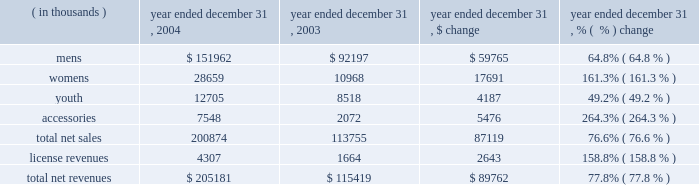2022 selling costs increased $ 5.4 million to $ 17.1 million in 2005 from $ 11.7 million in 2004 .
This increase was due to increased headcount in our sales force and startup costs associated with our international growth initiatives .
As a percentage of net revenues , selling costs increased to 6.1% ( 6.1 % ) in 2005 from 5.7% ( 5.7 % ) in 2004 due to the increased costs described above .
2022 payroll and related costs ( excluding those specifically related to marketing and selling ) increased $ 8.6 million to $ 26.9 million in 2005 , from $ 18.3 million in 2004 .
The increase during 2005 was due to the following initiatives : we began to build our team to design and source our footwear line , which we expect to offer for the fall 2006 season , we added personnel to our information technology team to support our company-wide initiative to upgrade our information systems , we incurred equity compensation costs , we added personnel to operate our 3 new retail outlet stores , and we invested in the personnel needed to enhance our compliance function and operate as a public company .
As a percentage of net revenues , payroll and related costs ( excluding those specifically related to marketing and selling ) increased to 9.6% ( 9.6 % ) in 2005 from 8.9% ( 8.9 % ) in 2004 due to the items described above .
2022 other corporate costs increased $ 7.2 million to $ 25.5 million in 2005 , from $ 18.3 million in 2004 .
This increase was attributable to higher costs in support of our footwear initiative , freight and duty related to increased canada sales , expansion of our leased corporate office space and distribution facility , and necessary costs associated with being a public company .
As a percentage of net revenues , other corporate costs were 9.1% ( 9.1 % ) in 2005 , which is a slight increase from 8.9% ( 8.9 % ) in 2004 due to the items noted above .
Income from operations increased $ 10.5 million , or 41.4% ( 41.4 % ) , to $ 35.9 million in 2005 from $ 25.4 million in 2004 .
Income from operations as a percentage of net revenues increased to 12.7% ( 12.7 % ) in 2005 from 12.4% ( 12.4 % ) in 2004 .
This increase was a result of an increase in gross margin partially offset by an increase in selling , general and administrative expenses as a percentage of net revenues .
Interest expense , net increased $ 1.6 million to $ 2.9 million in 2005 from $ 1.3 million in 2004 .
This increase was primarily due to higher average borrowings and a higher effective interest rate under our revolving credit facility prior to being repaid in november 2005 with proceeds from the initial public offering .
Provision for income taxes increased $ 5.5 million to $ 13.3 million in 2005 from $ 7.8 million in 2004 .
For the year ended december 31 , 2005 our effective tax rate was 40.2% ( 40.2 % ) compared to 32.3% ( 32.3 % ) in 2004 .
This increase was primarily due to an increase in our effective state tax rate , which reflected reduced state tax credits earned as a percentage of income before taxes .
Net income increased $ 3.4 million to $ 19.7 million in 2005 from $ 16.3 million in 2004 , as a result of the factors described above .
Year ended december 31 , 2004 compared to year ended december 31 , 2003 net revenues increased $ 89.8 million , or 77.8% ( 77.8 % ) , to $ 205.2 million in 2004 from $ 115.4 million in 2003 .
The increase was a result of increases in both our net sales and license revenues as noted in the product category table below. .

What was the percent of growth in total net revenues from 2003 to 2004? 
Computations: ((205181 - 115419) / 115419)
Answer: 0.77771. 2022 selling costs increased $ 5.4 million to $ 17.1 million in 2005 from $ 11.7 million in 2004 .
This increase was due to increased headcount in our sales force and startup costs associated with our international growth initiatives .
As a percentage of net revenues , selling costs increased to 6.1% ( 6.1 % ) in 2005 from 5.7% ( 5.7 % ) in 2004 due to the increased costs described above .
2022 payroll and related costs ( excluding those specifically related to marketing and selling ) increased $ 8.6 million to $ 26.9 million in 2005 , from $ 18.3 million in 2004 .
The increase during 2005 was due to the following initiatives : we began to build our team to design and source our footwear line , which we expect to offer for the fall 2006 season , we added personnel to our information technology team to support our company-wide initiative to upgrade our information systems , we incurred equity compensation costs , we added personnel to operate our 3 new retail outlet stores , and we invested in the personnel needed to enhance our compliance function and operate as a public company .
As a percentage of net revenues , payroll and related costs ( excluding those specifically related to marketing and selling ) increased to 9.6% ( 9.6 % ) in 2005 from 8.9% ( 8.9 % ) in 2004 due to the items described above .
2022 other corporate costs increased $ 7.2 million to $ 25.5 million in 2005 , from $ 18.3 million in 2004 .
This increase was attributable to higher costs in support of our footwear initiative , freight and duty related to increased canada sales , expansion of our leased corporate office space and distribution facility , and necessary costs associated with being a public company .
As a percentage of net revenues , other corporate costs were 9.1% ( 9.1 % ) in 2005 , which is a slight increase from 8.9% ( 8.9 % ) in 2004 due to the items noted above .
Income from operations increased $ 10.5 million , or 41.4% ( 41.4 % ) , to $ 35.9 million in 2005 from $ 25.4 million in 2004 .
Income from operations as a percentage of net revenues increased to 12.7% ( 12.7 % ) in 2005 from 12.4% ( 12.4 % ) in 2004 .
This increase was a result of an increase in gross margin partially offset by an increase in selling , general and administrative expenses as a percentage of net revenues .
Interest expense , net increased $ 1.6 million to $ 2.9 million in 2005 from $ 1.3 million in 2004 .
This increase was primarily due to higher average borrowings and a higher effective interest rate under our revolving credit facility prior to being repaid in november 2005 with proceeds from the initial public offering .
Provision for income taxes increased $ 5.5 million to $ 13.3 million in 2005 from $ 7.8 million in 2004 .
For the year ended december 31 , 2005 our effective tax rate was 40.2% ( 40.2 % ) compared to 32.3% ( 32.3 % ) in 2004 .
This increase was primarily due to an increase in our effective state tax rate , which reflected reduced state tax credits earned as a percentage of income before taxes .
Net income increased $ 3.4 million to $ 19.7 million in 2005 from $ 16.3 million in 2004 , as a result of the factors described above .
Year ended december 31 , 2004 compared to year ended december 31 , 2003 net revenues increased $ 89.8 million , or 77.8% ( 77.8 % ) , to $ 205.2 million in 2004 from $ 115.4 million in 2003 .
The increase was a result of increases in both our net sales and license revenues as noted in the product category table below. .

What was the percent of the increase in interest expense from 2004 to 2005? 
Computations: (1.6 / 1.3)
Answer: 1.23077. 